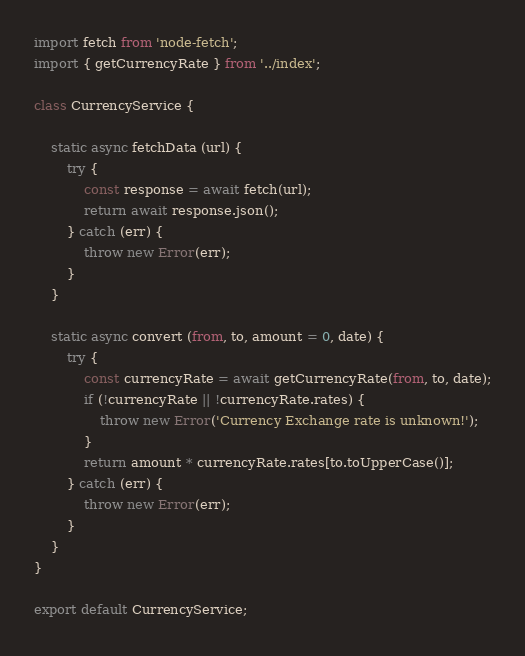<code> <loc_0><loc_0><loc_500><loc_500><_JavaScript_>import fetch from 'node-fetch';
import { getCurrencyRate } from '../index';

class CurrencyService {

    static async fetchData (url) {
        try {
            const response = await fetch(url);
            return await response.json();
        } catch (err) {
            throw new Error(err);
        }
    }

    static async convert (from, to, amount = 0, date) {
        try {
            const currencyRate = await getCurrencyRate(from, to, date);
            if (!currencyRate || !currencyRate.rates) {
                throw new Error('Currency Exchange rate is unknown!');
            }
            return amount * currencyRate.rates[to.toUpperCase()];
        } catch (err) {
            throw new Error(err);
        }
    }
}

export default CurrencyService;</code> 